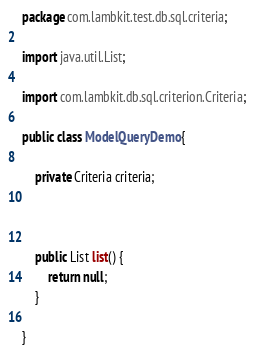Convert code to text. <code><loc_0><loc_0><loc_500><loc_500><_Java_>package com.lambkit.test.db.sql.criteria;

import java.util.List;

import com.lambkit.db.sql.criterion.Criteria;

public class ModelQueryDemo {

	private Criteria criteria;
	
	
	
	public List list() {
		return null;
	}
	
}
</code> 